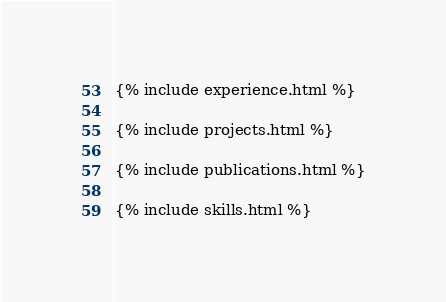Convert code to text. <code><loc_0><loc_0><loc_500><loc_500><_HTML_>{% include experience.html %}
            
{% include projects.html %}

{% include publications.html %}
            
{% include skills.html %}


</code> 